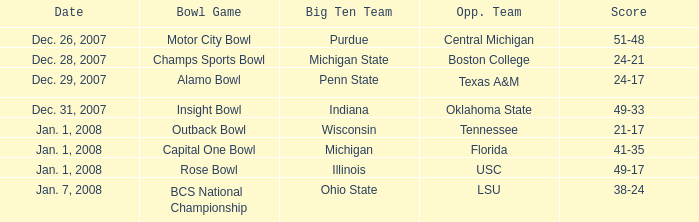Who faced purdue in the competition? Central Michigan. 